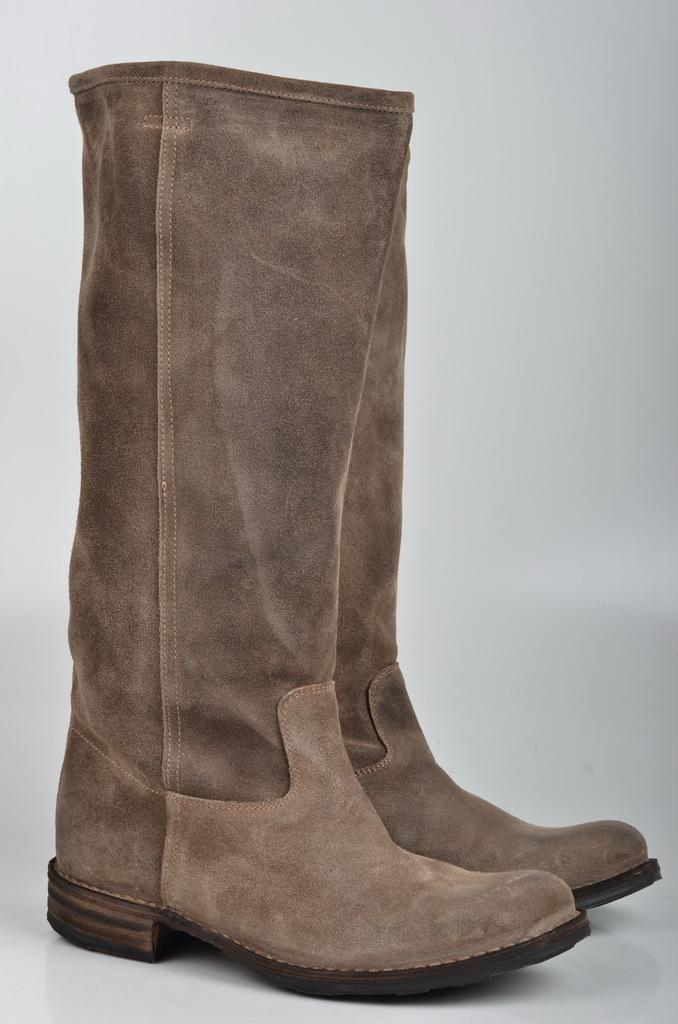What type of footwear is visible in the image? There is a pair of boots in the image. How many pizzas are being served on the line during the holiday in the image? There is no reference to pizzas, a line, or a holiday in the image; it only features a pair of boots. 